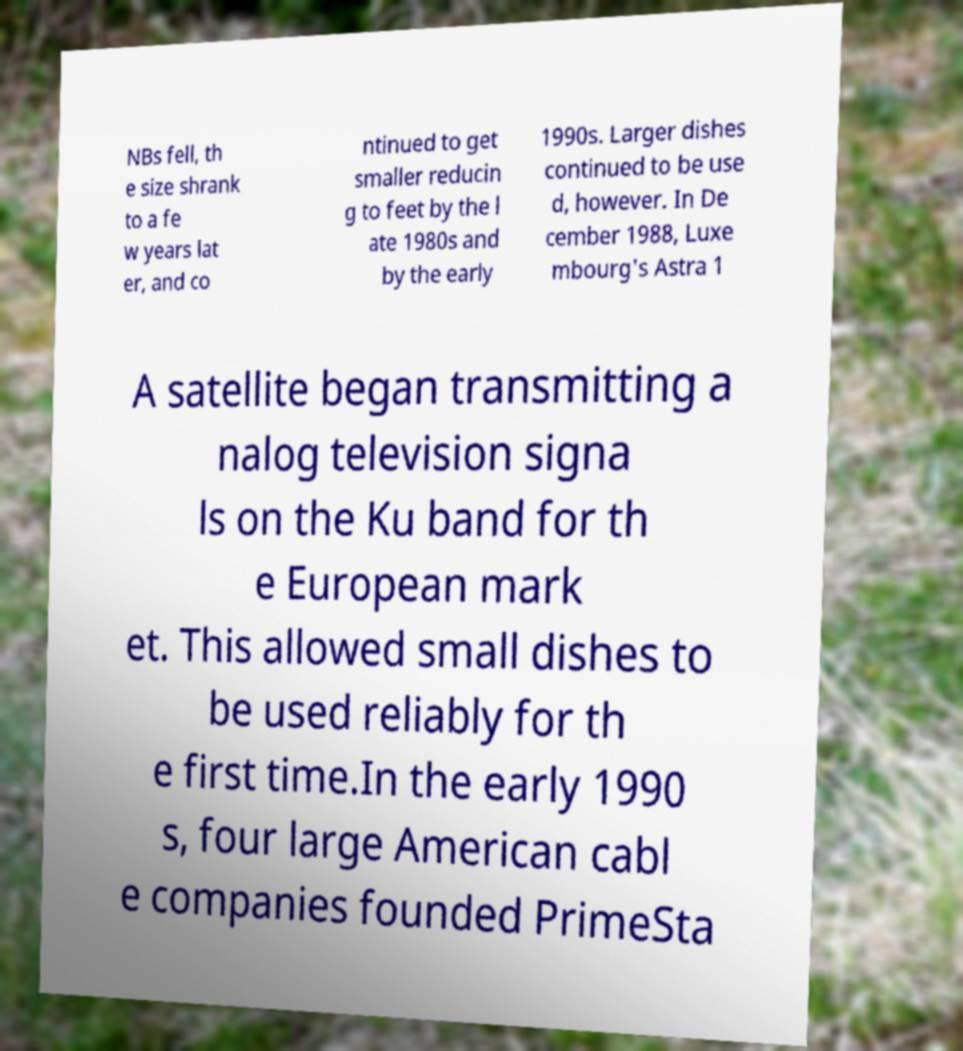Could you extract and type out the text from this image? NBs fell, th e size shrank to a fe w years lat er, and co ntinued to get smaller reducin g to feet by the l ate 1980s and by the early 1990s. Larger dishes continued to be use d, however. In De cember 1988, Luxe mbourg's Astra 1 A satellite began transmitting a nalog television signa ls on the Ku band for th e European mark et. This allowed small dishes to be used reliably for th e first time.In the early 1990 s, four large American cabl e companies founded PrimeSta 